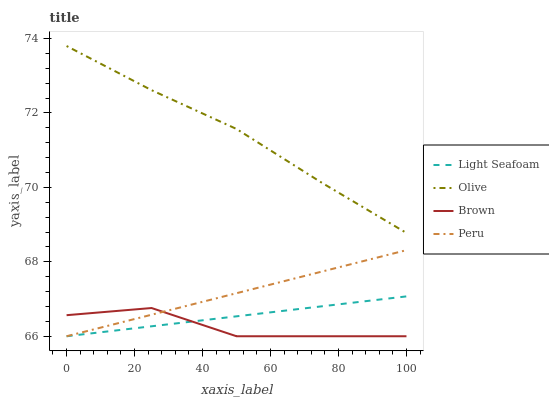Does Light Seafoam have the minimum area under the curve?
Answer yes or no. No. Does Light Seafoam have the maximum area under the curve?
Answer yes or no. No. Is Brown the smoothest?
Answer yes or no. No. Is Light Seafoam the roughest?
Answer yes or no. No. Does Light Seafoam have the highest value?
Answer yes or no. No. Is Brown less than Olive?
Answer yes or no. Yes. Is Olive greater than Brown?
Answer yes or no. Yes. Does Brown intersect Olive?
Answer yes or no. No. 